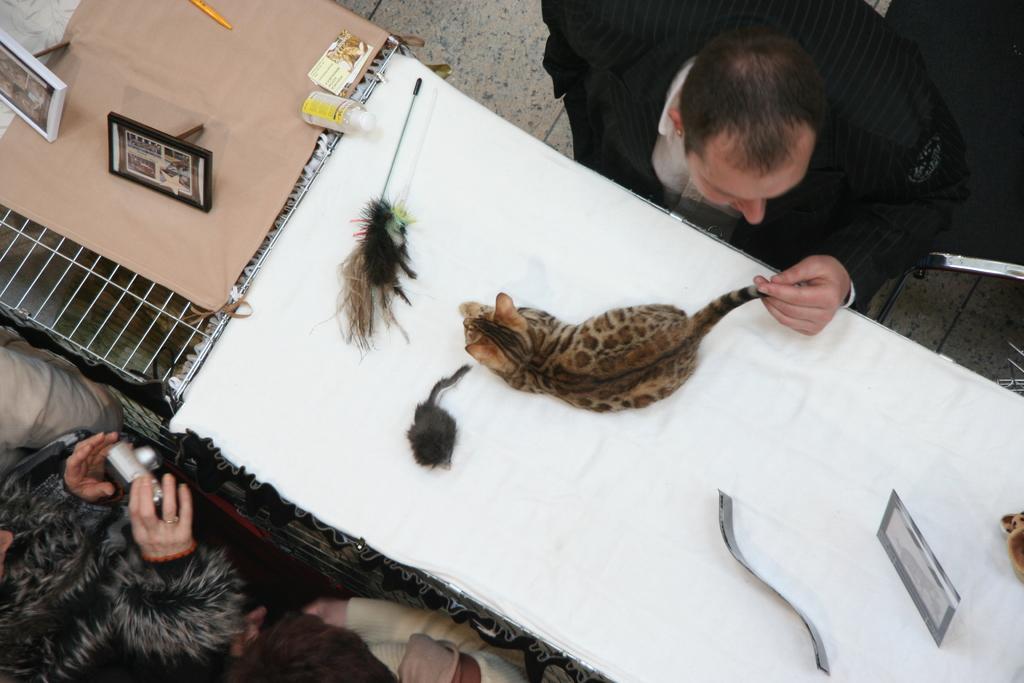Please provide a concise description of this image. In this image I can see there is a cat, a rat and some photo frames on the table and there is a man holding the cats tail and there are some other people standing here on left side. 